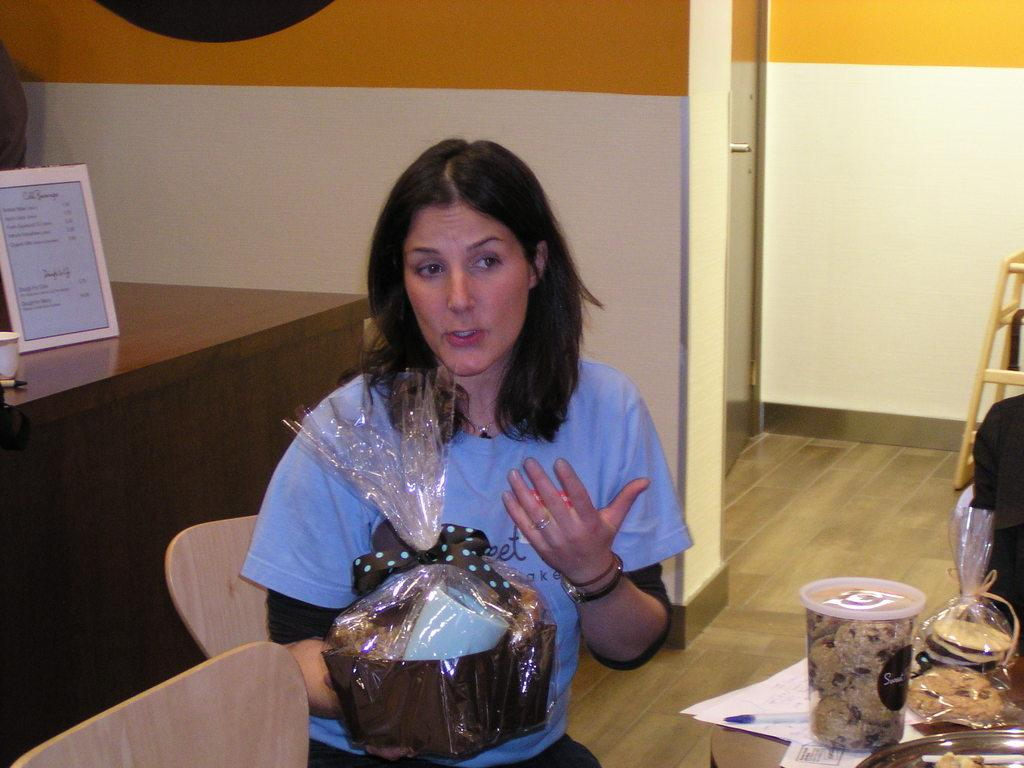What is the woman holding in the image? There is a woman holding an object in the image. What else can be seen in the image besides the woman? There are food items, paper, a board, chairs, and a wooden bench in the image. What might the woman be using the object for? It is unclear from the image what the woman is using the object for. What type of surface is the board placed on? The board is placed on a table or another flat surface, but the specific material is not mentioned. How many legs can be seen on the loaf of bread in the image? There is no loaf of bread present in the image, and therefore no legs can be seen on it. 